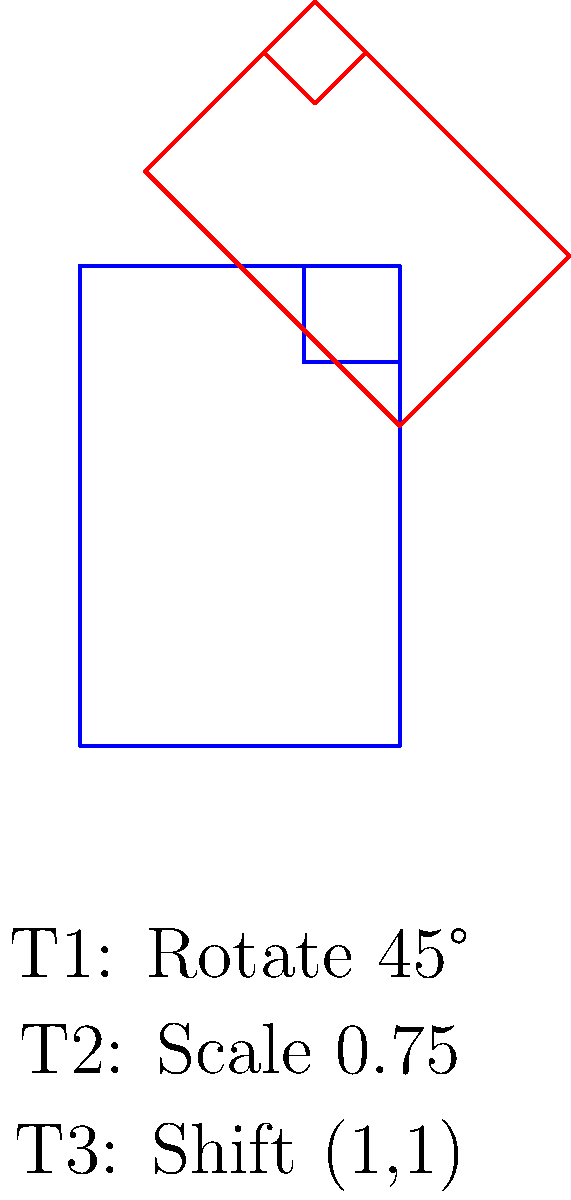In a digital repository system, a document icon undergoes a series of transformations to represent different versions. The original icon is subjected to three consecutive transformations: T1 (rotation by 45°), T2 (scaling by 0.75), and T3 (translation by (1,1)). What is the composite transformation matrix that represents this sequence of transformations? To find the composite transformation matrix, we need to multiply the individual transformation matrices in the correct order (from right to left, as transformations are applied).

Step 1: Rotation matrix (T1)
$$R = \begin{bmatrix} \cos 45° & -\sin 45° \\ \sin 45° & \cos 45° \end{bmatrix} = \begin{bmatrix} \frac{\sqrt{2}}{2} & -\frac{\sqrt{2}}{2} \\ \frac{\sqrt{2}}{2} & \frac{\sqrt{2}}{2} \end{bmatrix}$$

Step 2: Scaling matrix (T2)
$$S = \begin{bmatrix} 0.75 & 0 \\ 0 & 0.75 \end{bmatrix}$$

Step 3: Translation matrix (T3)
In homogeneous coordinates:
$$T = \begin{bmatrix} 1 & 0 & 1 \\ 0 & 1 & 1 \\ 0 & 0 & 1 \end{bmatrix}$$

Step 4: Composite transformation
$$C = T * S * R$$

$$C = \begin{bmatrix} 1 & 0 & 1 \\ 0 & 1 & 1 \\ 0 & 0 & 1 \end{bmatrix} * \begin{bmatrix} 0.75 & 0 & 0 \\ 0 & 0.75 & 0 \\ 0 & 0 & 1 \end{bmatrix} * \begin{bmatrix} \frac{\sqrt{2}}{2} & -\frac{\sqrt{2}}{2} & 0 \\ \frac{\sqrt{2}}{2} & \frac{\sqrt{2}}{2} & 0 \\ 0 & 0 & 1 \end{bmatrix}$$

Multiplying these matrices:

$$C = \begin{bmatrix} 0.75\frac{\sqrt{2}}{2} & -0.75\frac{\sqrt{2}}{2} & 1 \\ 0.75\frac{\sqrt{2}}{2} & 0.75\frac{\sqrt{2}}{2} & 1 \\ 0 & 0 & 1 \end{bmatrix}$$
Answer: $$\begin{bmatrix} 0.75\frac{\sqrt{2}}{2} & -0.75\frac{\sqrt{2}}{2} & 1 \\ 0.75\frac{\sqrt{2}}{2} & 0.75\frac{\sqrt{2}}{2} & 1 \\ 0 & 0 & 1 \end{bmatrix}$$ 